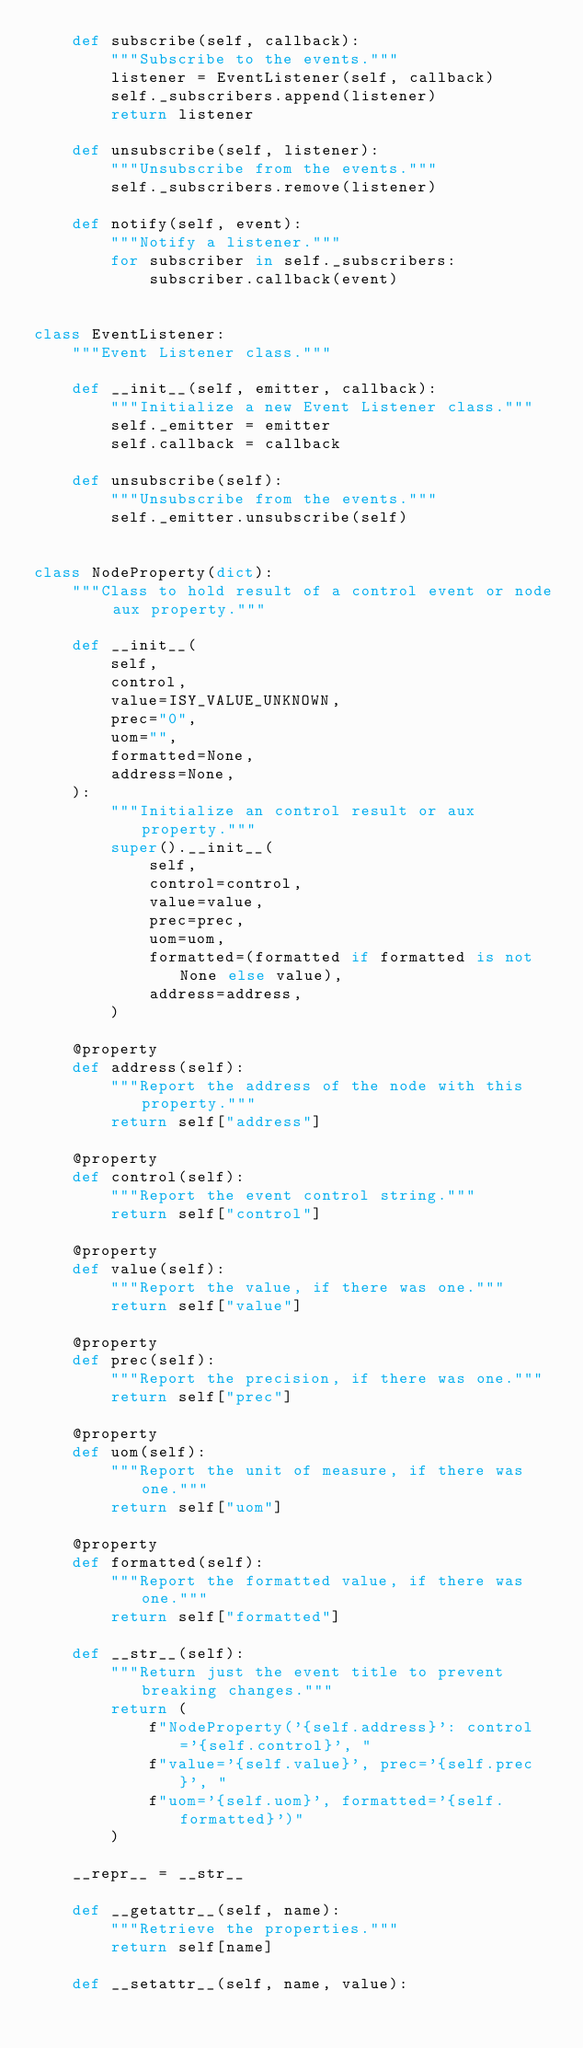Convert code to text. <code><loc_0><loc_0><loc_500><loc_500><_Python_>    def subscribe(self, callback):
        """Subscribe to the events."""
        listener = EventListener(self, callback)
        self._subscribers.append(listener)
        return listener

    def unsubscribe(self, listener):
        """Unsubscribe from the events."""
        self._subscribers.remove(listener)

    def notify(self, event):
        """Notify a listener."""
        for subscriber in self._subscribers:
            subscriber.callback(event)


class EventListener:
    """Event Listener class."""

    def __init__(self, emitter, callback):
        """Initialize a new Event Listener class."""
        self._emitter = emitter
        self.callback = callback

    def unsubscribe(self):
        """Unsubscribe from the events."""
        self._emitter.unsubscribe(self)


class NodeProperty(dict):
    """Class to hold result of a control event or node aux property."""

    def __init__(
        self,
        control,
        value=ISY_VALUE_UNKNOWN,
        prec="0",
        uom="",
        formatted=None,
        address=None,
    ):
        """Initialize an control result or aux property."""
        super().__init__(
            self,
            control=control,
            value=value,
            prec=prec,
            uom=uom,
            formatted=(formatted if formatted is not None else value),
            address=address,
        )

    @property
    def address(self):
        """Report the address of the node with this property."""
        return self["address"]

    @property
    def control(self):
        """Report the event control string."""
        return self["control"]

    @property
    def value(self):
        """Report the value, if there was one."""
        return self["value"]

    @property
    def prec(self):
        """Report the precision, if there was one."""
        return self["prec"]

    @property
    def uom(self):
        """Report the unit of measure, if there was one."""
        return self["uom"]

    @property
    def formatted(self):
        """Report the formatted value, if there was one."""
        return self["formatted"]

    def __str__(self):
        """Return just the event title to prevent breaking changes."""
        return (
            f"NodeProperty('{self.address}': control='{self.control}', "
            f"value='{self.value}', prec='{self.prec}', "
            f"uom='{self.uom}', formatted='{self.formatted}')"
        )

    __repr__ = __str__

    def __getattr__(self, name):
        """Retrieve the properties."""
        return self[name]

    def __setattr__(self, name, value):</code> 